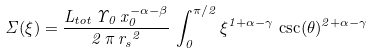Convert formula to latex. <formula><loc_0><loc_0><loc_500><loc_500>\Sigma ( \xi ) = \frac { L _ { t o t } \, \Upsilon _ { 0 } \, x _ { 0 } ^ { - \alpha - \beta } } { 2 \, \pi \, { r _ { s } } ^ { 2 } } \, \int _ { 0 } ^ { \pi / 2 } \xi ^ { 1 + \alpha - \gamma } \, \csc ( \theta ) ^ { 2 + \alpha - \gamma }</formula> 